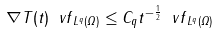<formula> <loc_0><loc_0><loc_500><loc_500>\| \nabla T ( t ) \ v f \| _ { L ^ { q } ( \varOmega ) } \leq C _ { q } t ^ { - \frac { 1 } { 2 } } \| \ v f \| _ { L ^ { q } ( \varOmega ) }</formula> 